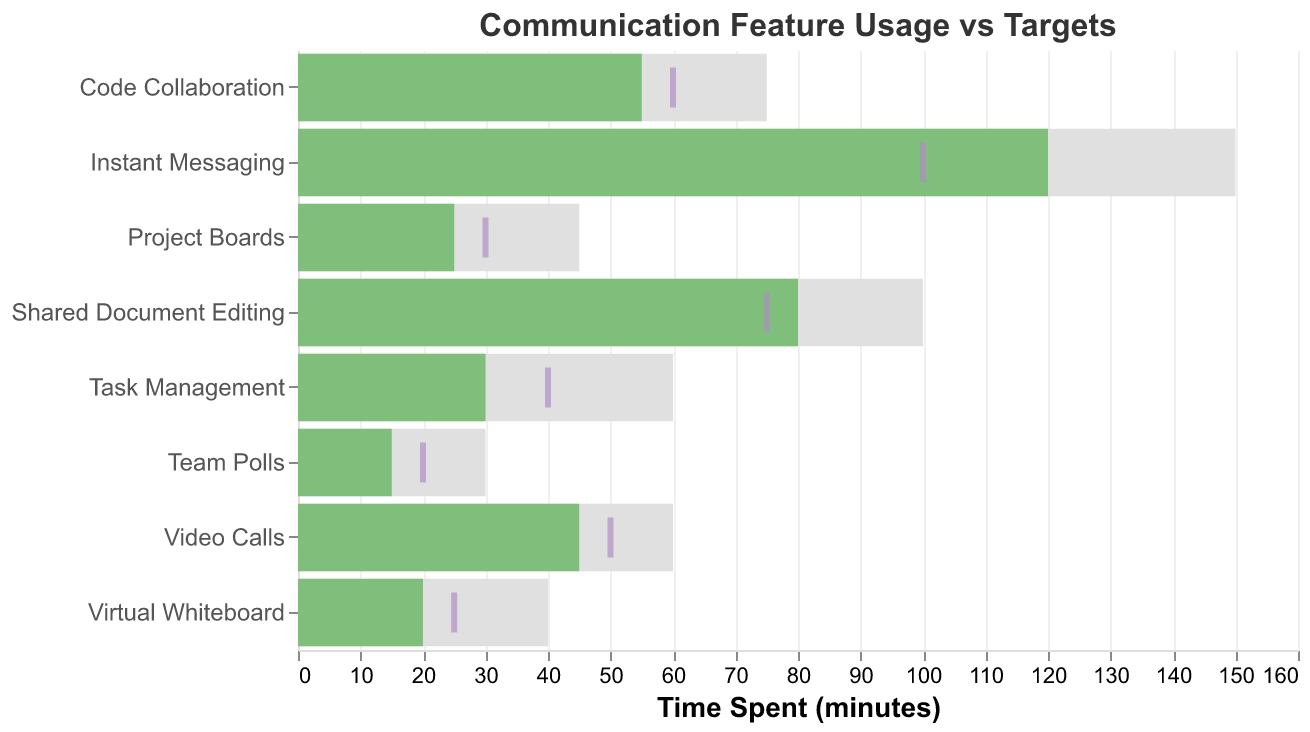what is the title of the chart? The title of the chart is "Communication Feature Usage vs Targets" which is located at the top of the chart.
Answer: Communication Feature Usage vs Targets How many features are displayed in the chart? By counting the number of distinct features listed on the Y-axis, we can see there are eight features displayed.
Answer: 8 Which feature has the highest actual time spent compared to its target? Looking at the green bars (actual time spent) and comparing them to the purple ticks (targets), the feature "Instant Messaging" has the highest actual time spent (120) compared to its target (100).
Answer: Instant Messaging How much more time is spent on Project Boards compared to Team Polls? The actual time spent on Project Boards is 25 minutes, and on Team Polls is 15 minutes. The difference is calculated as 25 - 15 = 10.
Answer: 10 minutes Which feature has the lowest actual time spent? By observing the green bars representing the actual time spent, "Team Polls" has the shortest bar indicating the lowest actual time spent of 15 minutes.
Answer: Team Polls Is the target for Virtual Whiteboard met? The actual time spent on Virtual Whiteboard is 20 minutes, while the target is 25 minutes, meaning the target is not met.
Answer: No How many features have exceeded their target times? Comparing the green bars (actual time spent) to the purple ticks (targets), three features have exceeded their target times: Instant Messaging (120 vs 100), Shared Document Editing (80 vs 75), and Virtual Whiteboard (20 vs 25).
Answer: 3 What is the average actual time spent across all features? Sum the actual times: 45 (Video Calls) + 120 (Instant Messaging) + 80 (Shared Document Editing) + 30 (Task Management) + 25 (Project Boards) + 15 (Team Polls) + 55 (Code Collaboration) + 20 (Virtual Whiteboard) = 390. There are 8 features, so the average is 390 / 8 = 48.75.
Answer: 48.75 minutes Which feature has the smallest difference between its maximum and actual time spent? Calculating the difference for each feature:
Video Calls: 60 - 45 = 15
Instant Messaging: 150 - 120 = 30
Shared Document Editing: 100 - 80 = 20
Task Management: 60 - 30 = 30
Project Boards: 45 - 25 = 20
Team Polls: 30 - 15 = 15
Code Collaboration: 75 - 55 = 20
Virtual Whiteboard: 40 - 20 = 20
The smallest difference is 15, observed for Video Calls and Team Polls.
Answer: Video Calls and Team Polls 